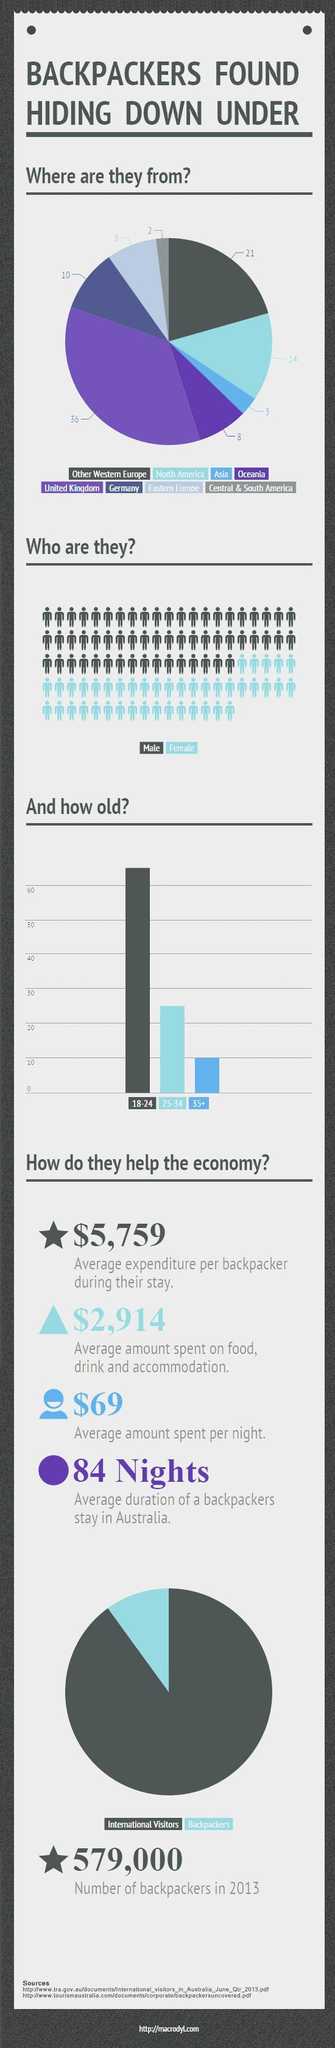List a handful of essential elements in this visual. The number of sources listed is two. The United Kingdom is the primary source of backpackers. Backpacking is least preferred among individuals aged 35 and above. It is more common for males to engage in backpacking. It is estimated that 14 backpackers from North America will participate in the event. 